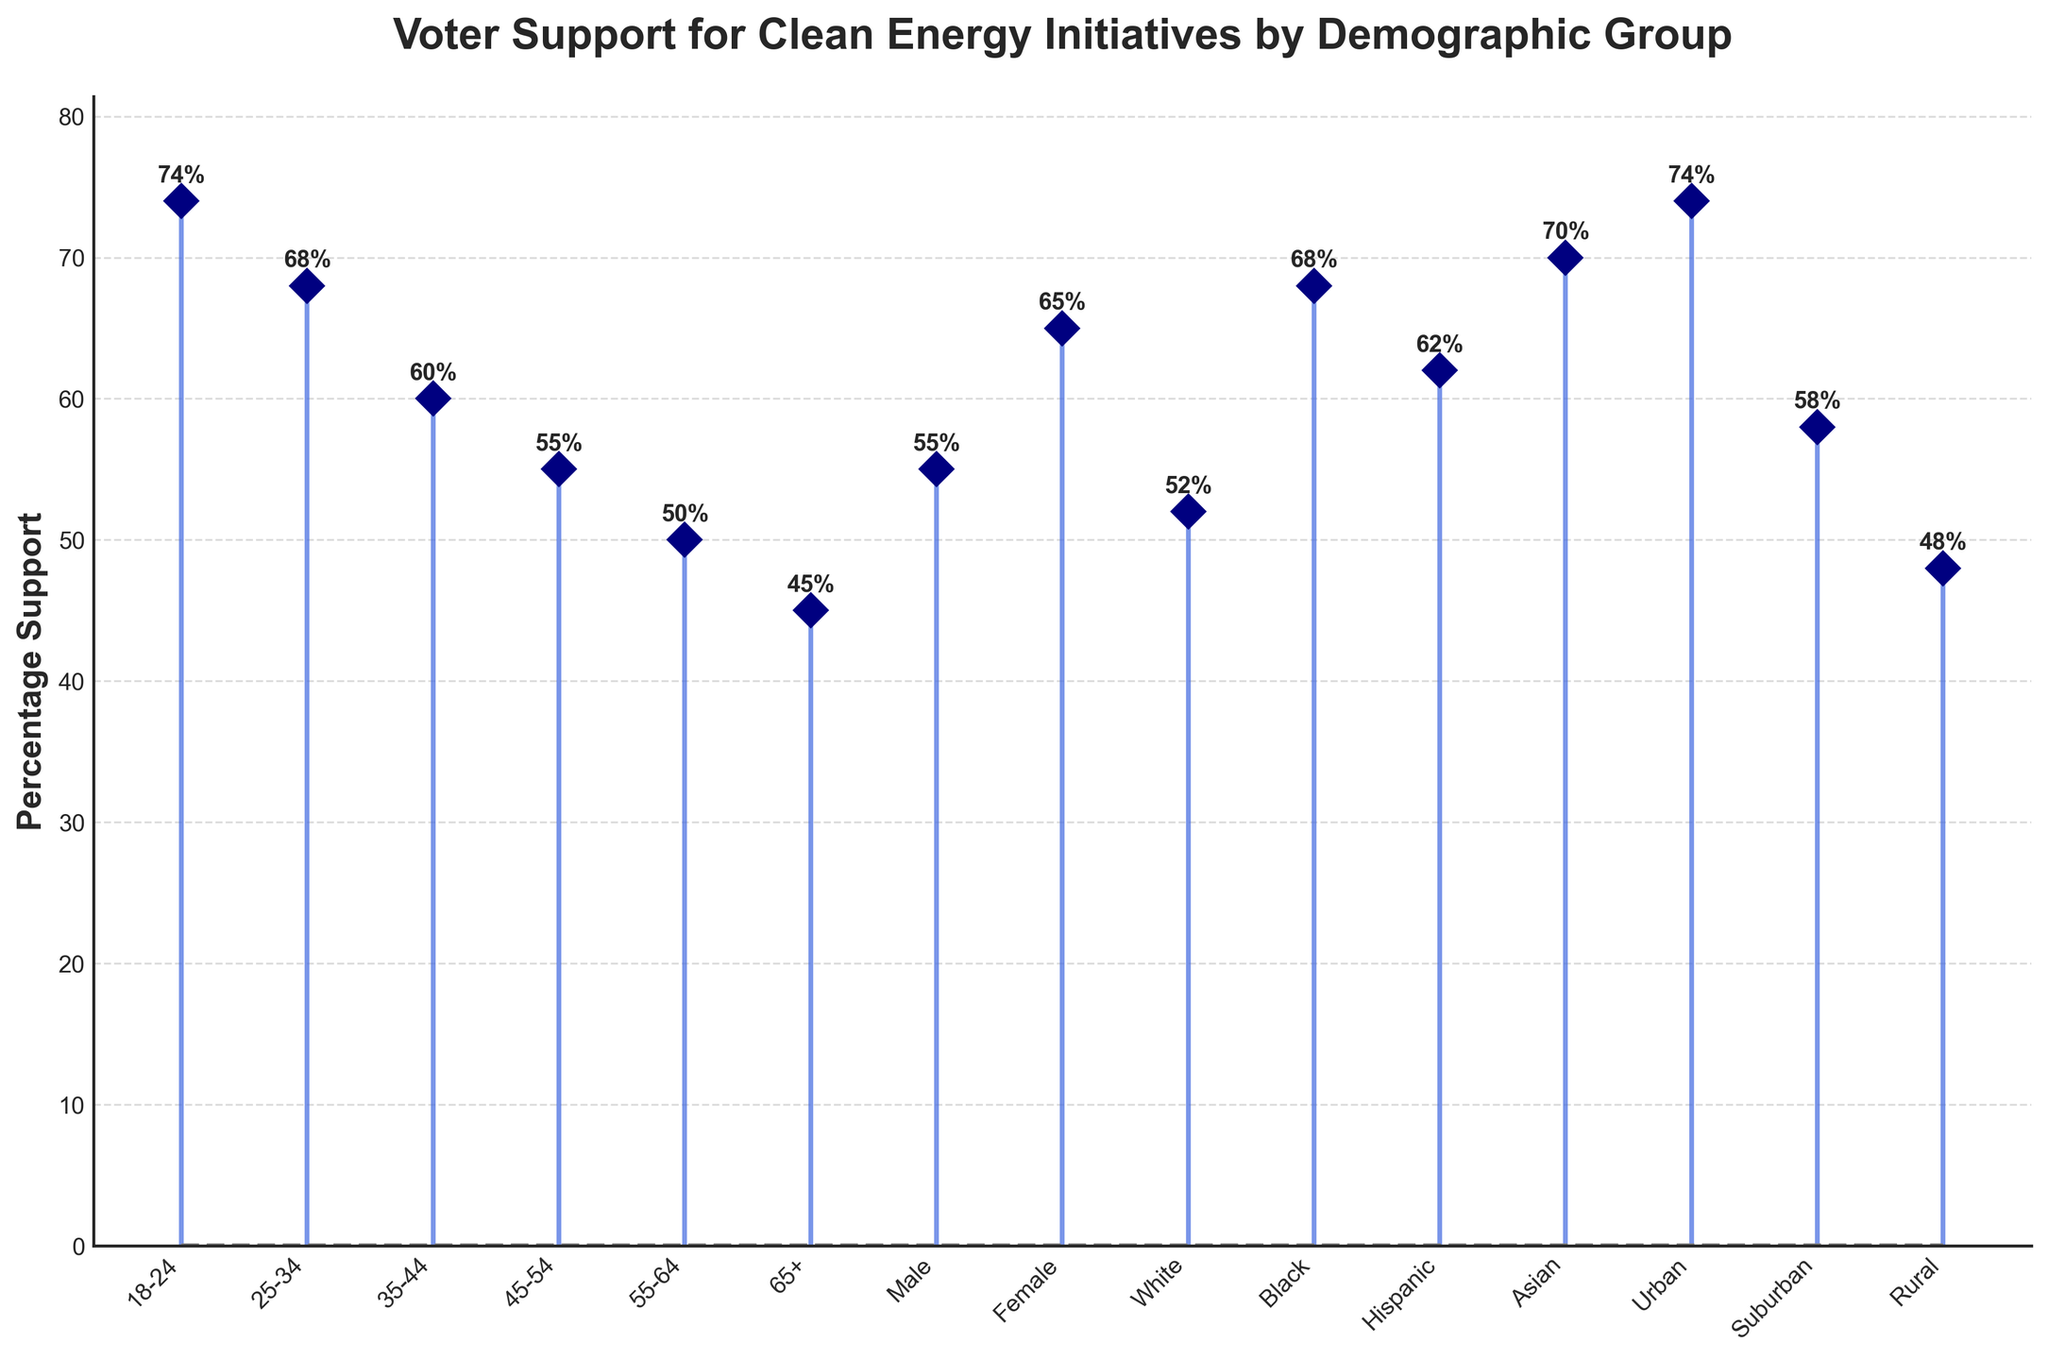What is the title of the plot? The title is clearly displayed at the top of the plot. It reads "Voter Support for Clean Energy Initiatives by Demographic Group".
Answer: Voter Support for Clean Energy Initiatives by Demographic Group How many demographic groups are presented in the plot? By counting the labeled tick marks along the x-axis, we see there are 15 demographic groups.
Answer: 15 Which demographic group has the highest percentage support for clean energy initiatives? From the plot, the group with the tallest stem is at the leftmost part of the x-axis. Its label is "18-24," and its percentage is 74%.
Answer: 18-24 How do the support percentages of urban and rural voters compare? Looking at the values for 'Urban' and 'Rural' groups, we see that Urban voters have a 74% support rate while Rural voters have a 48% support rate. Comparing these values, Urban voters have higher support.
Answer: Urban voters have higher support What's the difference in percentage support between the age group 18-24 and the age group 65+? The percentage support for the age group 18-24 is 74% and for 65+ it is 45%. Subtracting these values gives 74% - 45% = 29%.
Answer: 29% Which gender has greater support for clean energy initiatives? By comparing the stems labeled 'Male' and 'Female', we see that Male has 55% and Female has 65%. Therefore, Female has greater support.
Answer: Female What's the average support percentage across all demographic groups? Summing all the given percentage supports: 74 + 68 + 60 + 55 + 50 + 45 + 55 + 65 + 52 + 68 + 62 + 70 + 74 + 58 + 48 = 904. Dividing by the number of groups, 904/15 ≈ 60.27%.
Answer: 60.27% Which ethnic group shows the highest support for clean energy initiatives? From the plot, the ethnic group with the tallest stem related to ethnicity is labeled 'Asian', with a percentage of 70%.
Answer: Asian 